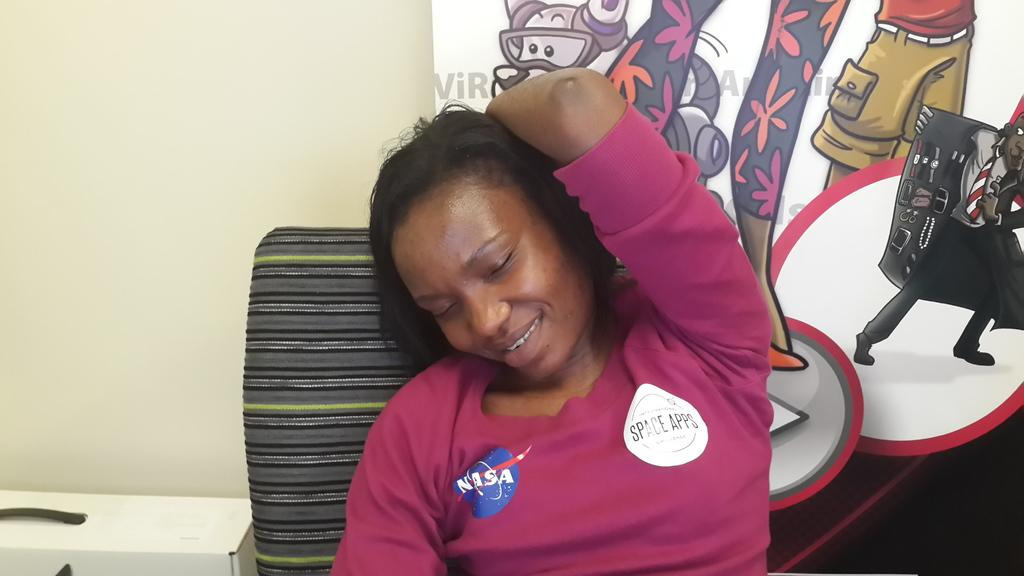Who is present in the image? There is a woman in the image. What is the woman doing in the image? The woman is sitting in a chair. What is the woman's facial expression in the image? The woman is smiling. What can be seen behind the woman in the image? There is a wall behind the woman. What type of addition is the woman performing in the image? There is no indication in the image that the woman is performing any addition. 